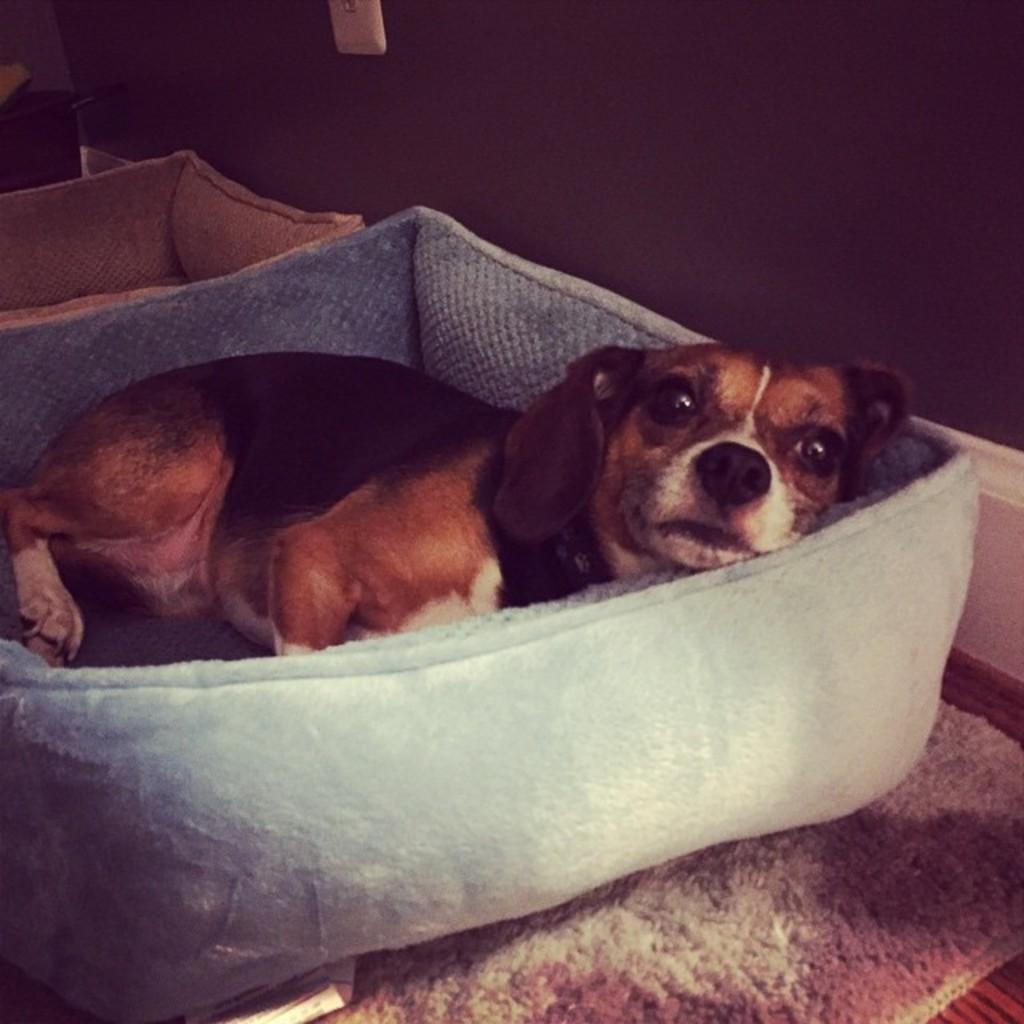Can you describe this image briefly? In this picture I can see a dog in a pet bed, there is another pet bed, there is a carpet, and in the background there is a wall. 